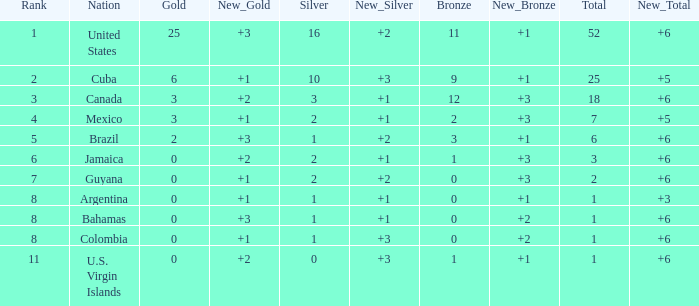What is the fewest number of silver medals a nation who ranked below 8 received? 0.0. 